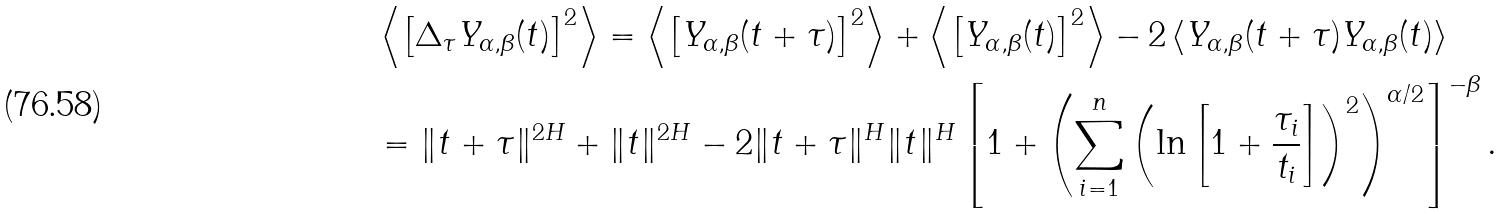Convert formula to latex. <formula><loc_0><loc_0><loc_500><loc_500>& \left \langle \left [ \Delta _ { \tau } Y _ { \alpha , \beta } ( t ) \right ] ^ { 2 } \right \rangle = \left \langle \left [ Y _ { \alpha , \beta } ( t + \tau ) \right ] ^ { 2 } \right \rangle + \left \langle \left [ Y _ { \alpha , \beta } ( t ) \right ] ^ { 2 } \right \rangle - 2 \left \langle Y _ { \alpha , \beta } ( t + \tau ) Y _ { \alpha , \beta } ( t ) \right \rangle \\ & = \| t + \tau \| ^ { 2 H } + \| t \| ^ { 2 H } - 2 \| t + \tau \| ^ { H } \| t \| ^ { H } \left [ 1 + \left ( \sum _ { i = 1 } ^ { n } \left ( \ln \left [ 1 + \frac { \tau _ { i } } { t _ { i } } \right ] \right ) ^ { 2 } \right ) ^ { \alpha / 2 } \right ] ^ { - \beta } .</formula> 